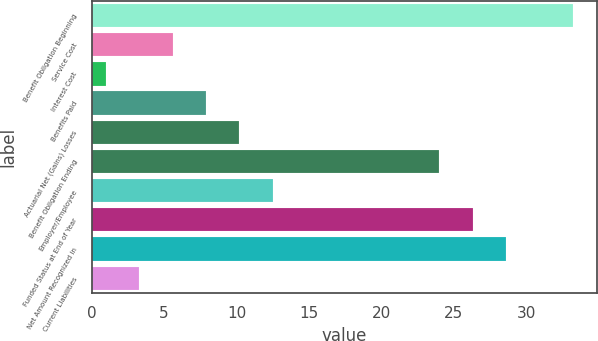Convert chart to OTSL. <chart><loc_0><loc_0><loc_500><loc_500><bar_chart><fcel>Benefit Obligation Beginning<fcel>Service Cost<fcel>Interest Cost<fcel>Benefits Paid<fcel>Actuarial Net (Gains) Losses<fcel>Benefit Obligation Ending<fcel>Employer/Employee<fcel>Funded Status at End of Year<fcel>Net Amount Recognized in<fcel>Current Liabilities<nl><fcel>33.2<fcel>5.6<fcel>1<fcel>7.9<fcel>10.2<fcel>24<fcel>12.5<fcel>26.3<fcel>28.6<fcel>3.3<nl></chart> 